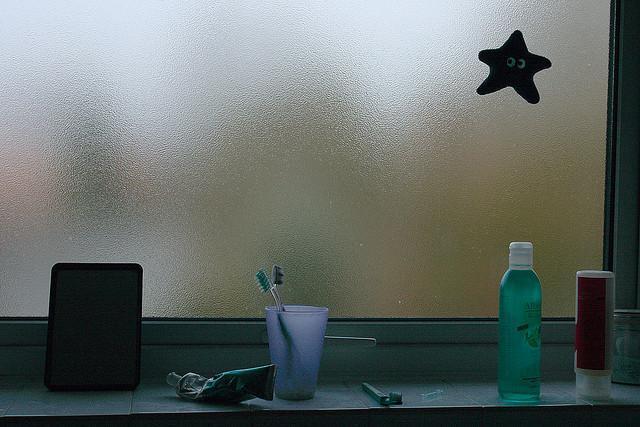How many toothbrushes are there?
Give a very brief answer. 2. How many bottles can you see?
Give a very brief answer. 2. How many people are wearing a checked top?
Give a very brief answer. 0. 